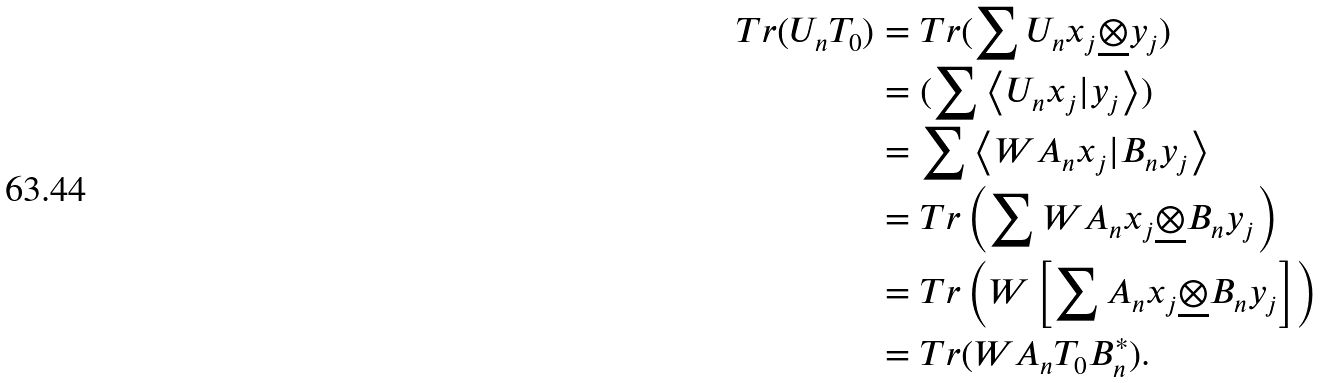<formula> <loc_0><loc_0><loc_500><loc_500>T r ( U _ { n } T _ { 0 } ) & = T r ( \sum U _ { n } x _ { j } \underline { \otimes } y _ { j } ) \\ & = ( \sum \left \langle U _ { n } x _ { j } | y _ { j } \right \rangle ) \\ & = \sum \left \langle W A _ { n } x _ { j } | B _ { n } y _ { j } \right \rangle \\ & = T r \left ( \sum W A _ { n } x _ { j } \underline { \otimes } B _ { n } y _ { j } \right ) \\ & = T r \left ( W \left [ \sum A _ { n } x _ { j } \underline { \otimes } B _ { n } y _ { j } \right ] \right ) \\ & = T r ( W A _ { n } T _ { 0 } B _ { n } ^ { * } ) .</formula> 